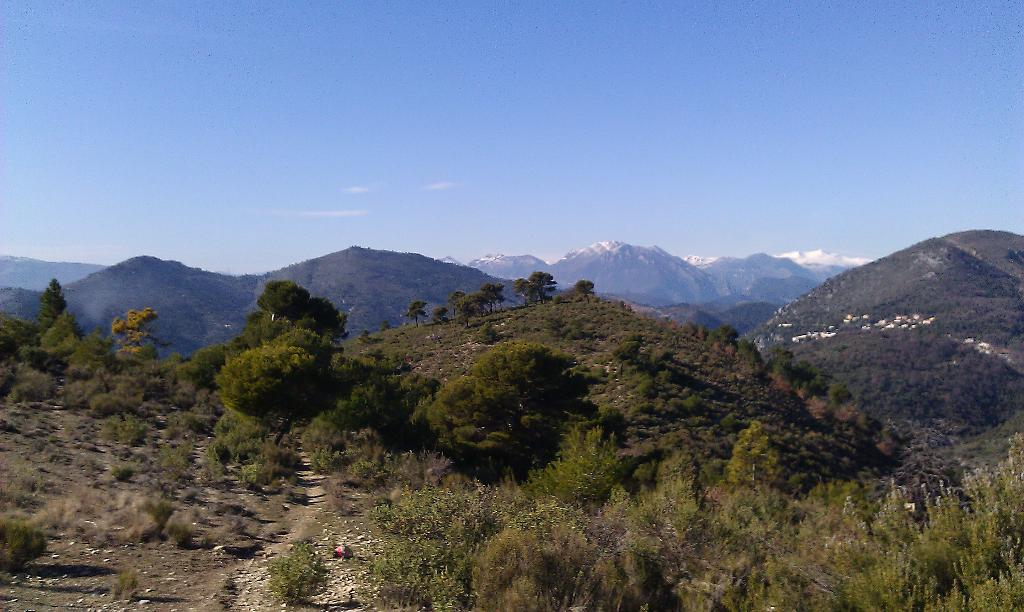What type of vegetation can be seen in the image? There are plants and trees visible in the image. What type of landscape feature is visible in the image? There are hills visible in the image. What color is the sky in the image? The sky is blue and visible at the top of the image. What type of dress is being worn by the plantation owner in the image? There is no plantation owner or dress present in the image; it features plants, trees, hills, and a blue sky. 